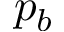<formula> <loc_0><loc_0><loc_500><loc_500>p _ { b }</formula> 